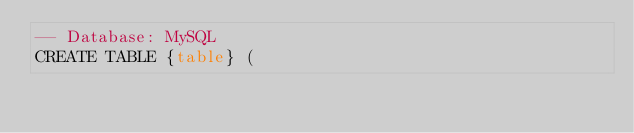<code> <loc_0><loc_0><loc_500><loc_500><_SQL_>-- Database: MySQL
CREATE TABLE {table} (</code> 